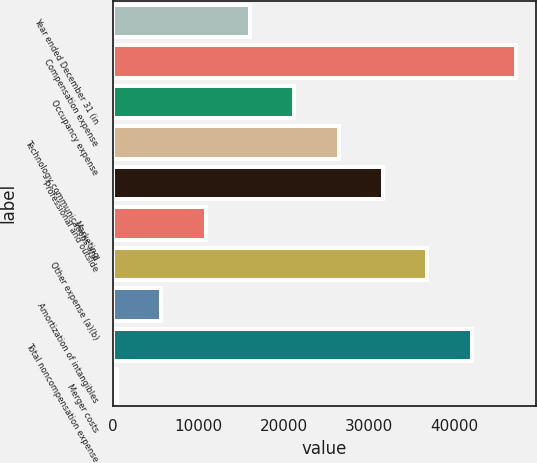Convert chart. <chart><loc_0><loc_0><loc_500><loc_500><bar_chart><fcel>Year ended December 31 (in<fcel>Compensation expense<fcel>Occupancy expense<fcel>Technology communications and<fcel>Professional and outside<fcel>Marketing<fcel>Other expense (a)(b)<fcel>Amortization of intangibles<fcel>Total noncompensation expense<fcel>Merger costs<nl><fcel>16042.3<fcel>47164.9<fcel>21229.4<fcel>26416.5<fcel>31603.6<fcel>10855.2<fcel>36790.7<fcel>5668.1<fcel>41977.8<fcel>481<nl></chart> 